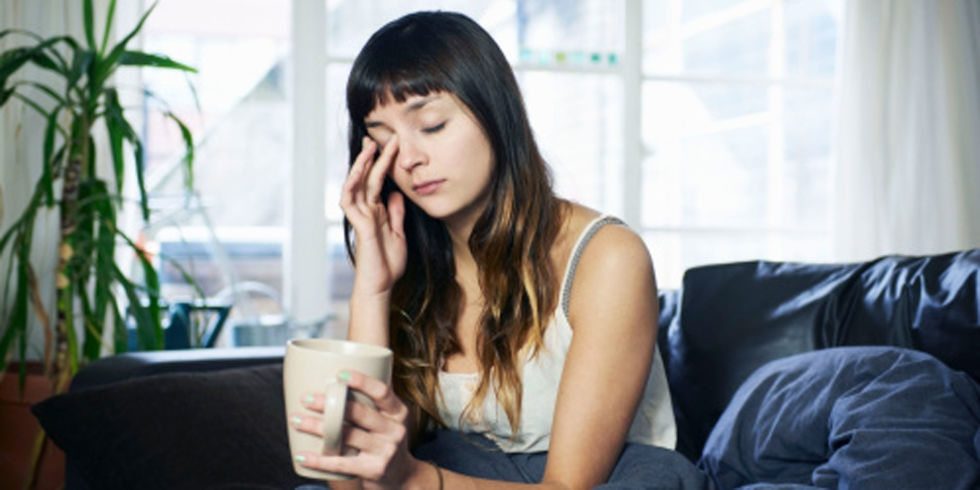What is the lighting like in the image? The lighting in the image could be described as ample, as there appears to be a sufficient amount of natural light coming through the window, illuminating the subject and surroundings in the room without any evident shadows or harshness. 